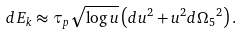Convert formula to latex. <formula><loc_0><loc_0><loc_500><loc_500>d E _ { k } \approx \tau _ { p } { \sqrt { \log u } } \left ( d u ^ { 2 } + u ^ { 2 } d { \Omega _ { 5 } } ^ { 2 } \right ) .</formula> 